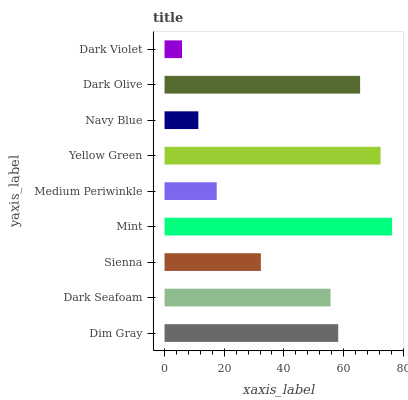Is Dark Violet the minimum?
Answer yes or no. Yes. Is Mint the maximum?
Answer yes or no. Yes. Is Dark Seafoam the minimum?
Answer yes or no. No. Is Dark Seafoam the maximum?
Answer yes or no. No. Is Dim Gray greater than Dark Seafoam?
Answer yes or no. Yes. Is Dark Seafoam less than Dim Gray?
Answer yes or no. Yes. Is Dark Seafoam greater than Dim Gray?
Answer yes or no. No. Is Dim Gray less than Dark Seafoam?
Answer yes or no. No. Is Dark Seafoam the high median?
Answer yes or no. Yes. Is Dark Seafoam the low median?
Answer yes or no. Yes. Is Sienna the high median?
Answer yes or no. No. Is Medium Periwinkle the low median?
Answer yes or no. No. 